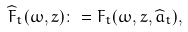<formula> <loc_0><loc_0><loc_500><loc_500>\widehat { F } _ { t } ( \omega , z ) \colon = F _ { t } ( \omega , z , \widehat { a } _ { t } ) ,</formula> 